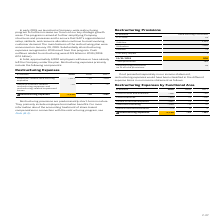According to Sap Ag's financial document, What was the Cost of services in 2019? According to the financial document, –154 (in millions). The relevant text states: "Cost of services –154 –3 –118..." Also, What was the Research and development in 2019? According to the financial document, –467 (in millions). The relevant text states: "Research and development –467 –3 –9..." Also, In which years are Restructuring Expenses by Functional Area calculated? The document contains multiple relevant values: 2019, 2018, 2017. From the document: "€ millions 2019 2018 2017 € millions 2019 2018 2017 € millions 2019 2018 2017..." Additionally, In which year was Cost of services largest? According to the financial document, 2019. The relevant text states: "€ millions 2019 2018 2017..." Also, can you calculate: What was the change in General and administration in 2018 from 2017? Based on the calculation: 0-2, the result is -2 (in millions). This is based on the information: "€ millions 2019 2018 2017 € millions 2019 2018 2017..." The key data points involved are: 0. Also, can you calculate: What was the percentage change in General and administration in 2018 from 2017? To answer this question, I need to perform calculations using the financial data. The calculation is: (0-2)/2, which equals -100 (percentage). This is based on the information: "€ millions 2019 2018 2017 € millions 2019 2018 2017..." The key data points involved are: 2. 